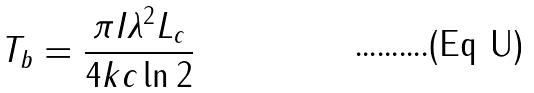<formula> <loc_0><loc_0><loc_500><loc_500>T _ { b } = \frac { \pi I \lambda ^ { 2 } L _ { c } } { 4 k c \ln 2 }</formula> 